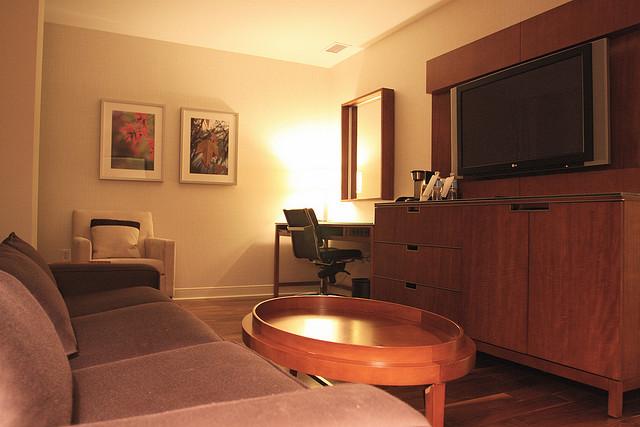Where is the pillow?
Answer briefly. On chair. What room is this?
Answer briefly. Living room. Is this a faucet?
Write a very short answer. No. Could this room be in a motel/hotel?
Write a very short answer. Yes. How many televisions are in this room?
Write a very short answer. 1. 